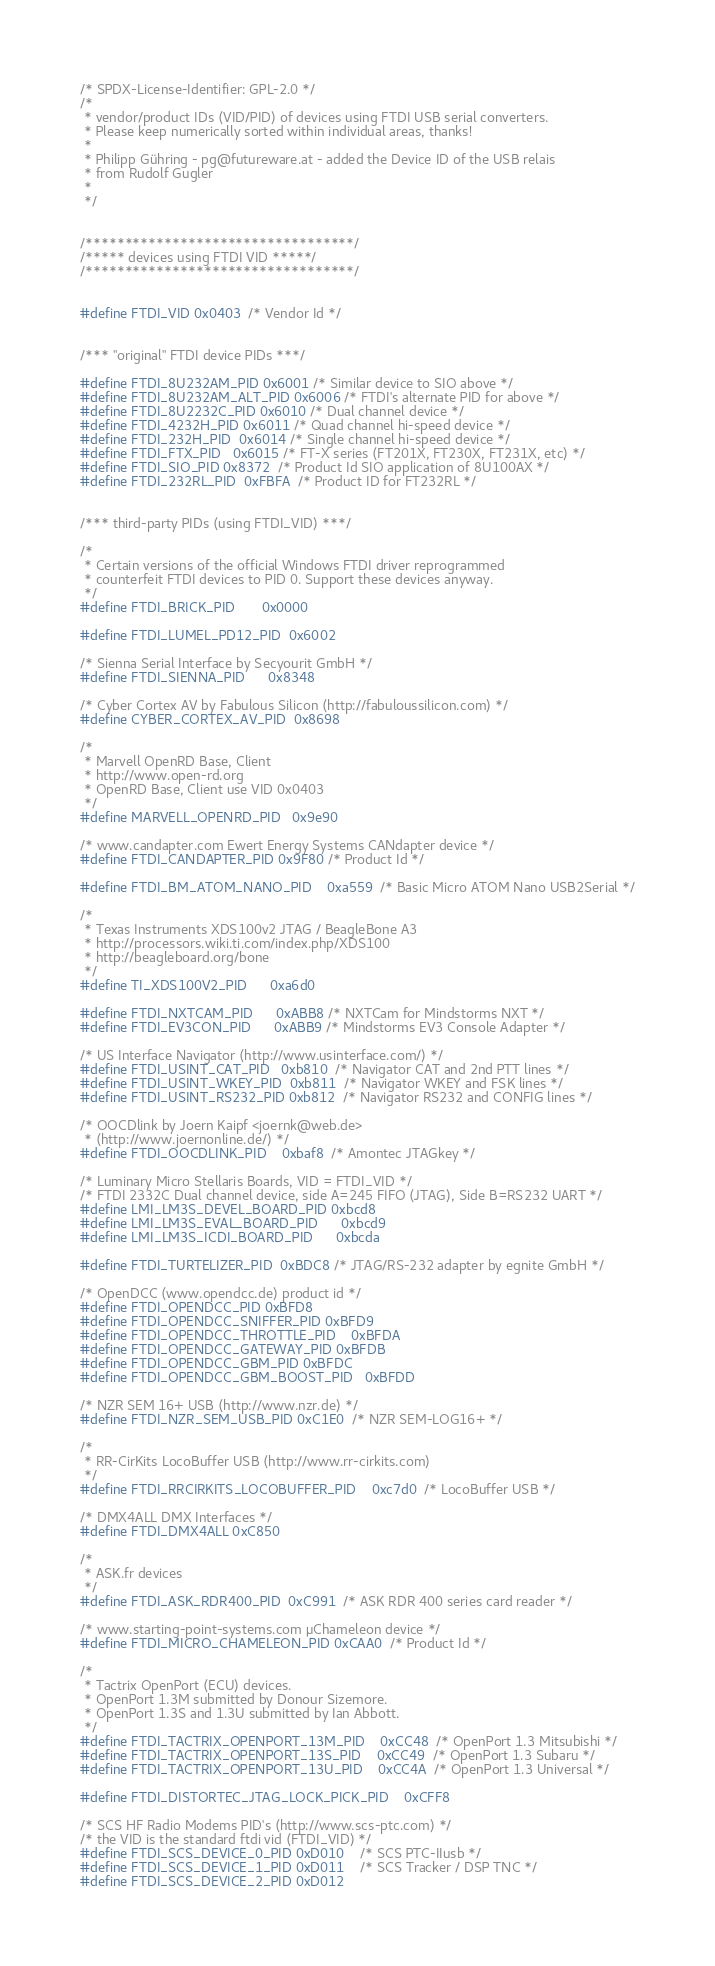<code> <loc_0><loc_0><loc_500><loc_500><_C_>/* SPDX-License-Identifier: GPL-2.0 */
/*
 * vendor/product IDs (VID/PID) of devices using FTDI USB serial converters.
 * Please keep numerically sorted within individual areas, thanks!
 *
 * Philipp Gühring - pg@futureware.at - added the Device ID of the USB relais
 * from Rudolf Gugler
 *
 */


/**********************************/
/***** devices using FTDI VID *****/
/**********************************/


#define FTDI_VID	0x0403	/* Vendor Id */


/*** "original" FTDI device PIDs ***/

#define FTDI_8U232AM_PID 0x6001 /* Similar device to SIO above */
#define FTDI_8U232AM_ALT_PID 0x6006 /* FTDI's alternate PID for above */
#define FTDI_8U2232C_PID 0x6010 /* Dual channel device */
#define FTDI_4232H_PID 0x6011 /* Quad channel hi-speed device */
#define FTDI_232H_PID  0x6014 /* Single channel hi-speed device */
#define FTDI_FTX_PID   0x6015 /* FT-X series (FT201X, FT230X, FT231X, etc) */
#define FTDI_SIO_PID	0x8372	/* Product Id SIO application of 8U100AX */
#define FTDI_232RL_PID  0xFBFA  /* Product ID for FT232RL */


/*** third-party PIDs (using FTDI_VID) ***/

/*
 * Certain versions of the official Windows FTDI driver reprogrammed
 * counterfeit FTDI devices to PID 0. Support these devices anyway.
 */
#define FTDI_BRICK_PID		0x0000

#define FTDI_LUMEL_PD12_PID	0x6002

/* Sienna Serial Interface by Secyourit GmbH */
#define FTDI_SIENNA_PID		0x8348

/* Cyber Cortex AV by Fabulous Silicon (http://fabuloussilicon.com) */
#define CYBER_CORTEX_AV_PID	0x8698

/*
 * Marvell OpenRD Base, Client
 * http://www.open-rd.org
 * OpenRD Base, Client use VID 0x0403
 */
#define MARVELL_OPENRD_PID	0x9e90

/* www.candapter.com Ewert Energy Systems CANdapter device */
#define FTDI_CANDAPTER_PID 0x9F80 /* Product Id */

#define FTDI_BM_ATOM_NANO_PID	0xa559	/* Basic Micro ATOM Nano USB2Serial */

/*
 * Texas Instruments XDS100v2 JTAG / BeagleBone A3
 * http://processors.wiki.ti.com/index.php/XDS100
 * http://beagleboard.org/bone
 */
#define TI_XDS100V2_PID		0xa6d0

#define FTDI_NXTCAM_PID		0xABB8 /* NXTCam for Mindstorms NXT */
#define FTDI_EV3CON_PID		0xABB9 /* Mindstorms EV3 Console Adapter */

/* US Interface Navigator (http://www.usinterface.com/) */
#define FTDI_USINT_CAT_PID	0xb810	/* Navigator CAT and 2nd PTT lines */
#define FTDI_USINT_WKEY_PID	0xb811	/* Navigator WKEY and FSK lines */
#define FTDI_USINT_RS232_PID	0xb812	/* Navigator RS232 and CONFIG lines */

/* OOCDlink by Joern Kaipf <joernk@web.de>
 * (http://www.joernonline.de/) */
#define FTDI_OOCDLINK_PID	0xbaf8	/* Amontec JTAGkey */

/* Luminary Micro Stellaris Boards, VID = FTDI_VID */
/* FTDI 2332C Dual channel device, side A=245 FIFO (JTAG), Side B=RS232 UART */
#define LMI_LM3S_DEVEL_BOARD_PID	0xbcd8
#define LMI_LM3S_EVAL_BOARD_PID		0xbcd9
#define LMI_LM3S_ICDI_BOARD_PID		0xbcda

#define FTDI_TURTELIZER_PID	0xBDC8 /* JTAG/RS-232 adapter by egnite GmbH */

/* OpenDCC (www.opendcc.de) product id */
#define FTDI_OPENDCC_PID	0xBFD8
#define FTDI_OPENDCC_SNIFFER_PID	0xBFD9
#define FTDI_OPENDCC_THROTTLE_PID	0xBFDA
#define FTDI_OPENDCC_GATEWAY_PID	0xBFDB
#define FTDI_OPENDCC_GBM_PID	0xBFDC
#define FTDI_OPENDCC_GBM_BOOST_PID	0xBFDD

/* NZR SEM 16+ USB (http://www.nzr.de) */
#define FTDI_NZR_SEM_USB_PID	0xC1E0	/* NZR SEM-LOG16+ */

/*
 * RR-CirKits LocoBuffer USB (http://www.rr-cirkits.com)
 */
#define FTDI_RRCIRKITS_LOCOBUFFER_PID	0xc7d0	/* LocoBuffer USB */

/* DMX4ALL DMX Interfaces */
#define FTDI_DMX4ALL 0xC850

/*
 * ASK.fr devices
 */
#define FTDI_ASK_RDR400_PID	0xC991	/* ASK RDR 400 series card reader */

/* www.starting-point-systems.com µChameleon device */
#define FTDI_MICRO_CHAMELEON_PID	0xCAA0	/* Product Id */

/*
 * Tactrix OpenPort (ECU) devices.
 * OpenPort 1.3M submitted by Donour Sizemore.
 * OpenPort 1.3S and 1.3U submitted by Ian Abbott.
 */
#define FTDI_TACTRIX_OPENPORT_13M_PID	0xCC48	/* OpenPort 1.3 Mitsubishi */
#define FTDI_TACTRIX_OPENPORT_13S_PID	0xCC49	/* OpenPort 1.3 Subaru */
#define FTDI_TACTRIX_OPENPORT_13U_PID	0xCC4A	/* OpenPort 1.3 Universal */

#define FTDI_DISTORTEC_JTAG_LOCK_PICK_PID	0xCFF8

/* SCS HF Radio Modems PID's (http://www.scs-ptc.com) */
/* the VID is the standard ftdi vid (FTDI_VID) */
#define FTDI_SCS_DEVICE_0_PID 0xD010    /* SCS PTC-IIusb */
#define FTDI_SCS_DEVICE_1_PID 0xD011    /* SCS Tracker / DSP TNC */
#define FTDI_SCS_DEVICE_2_PID 0xD012</code> 